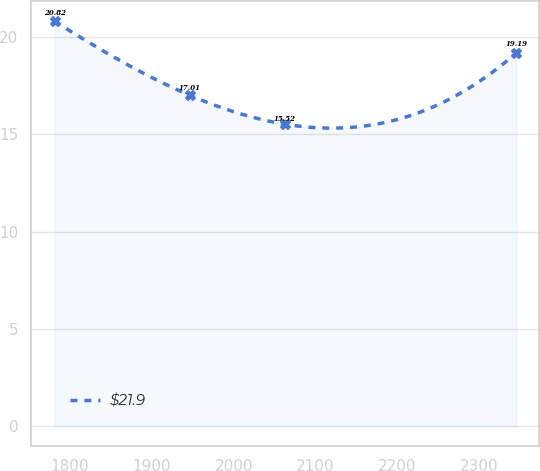Convert chart. <chart><loc_0><loc_0><loc_500><loc_500><line_chart><ecel><fcel>$21.9<nl><fcel>1781.29<fcel>20.82<nl><fcel>1946.29<fcel>17.01<nl><fcel>2062.8<fcel>15.52<nl><fcel>2345.36<fcel>19.19<nl></chart> 